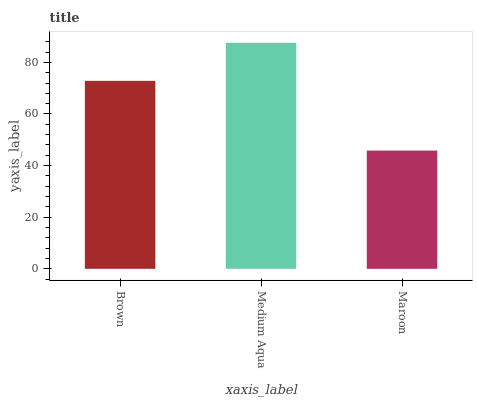Is Maroon the minimum?
Answer yes or no. Yes. Is Medium Aqua the maximum?
Answer yes or no. Yes. Is Medium Aqua the minimum?
Answer yes or no. No. Is Maroon the maximum?
Answer yes or no. No. Is Medium Aqua greater than Maroon?
Answer yes or no. Yes. Is Maroon less than Medium Aqua?
Answer yes or no. Yes. Is Maroon greater than Medium Aqua?
Answer yes or no. No. Is Medium Aqua less than Maroon?
Answer yes or no. No. Is Brown the high median?
Answer yes or no. Yes. Is Brown the low median?
Answer yes or no. Yes. Is Medium Aqua the high median?
Answer yes or no. No. Is Medium Aqua the low median?
Answer yes or no. No. 